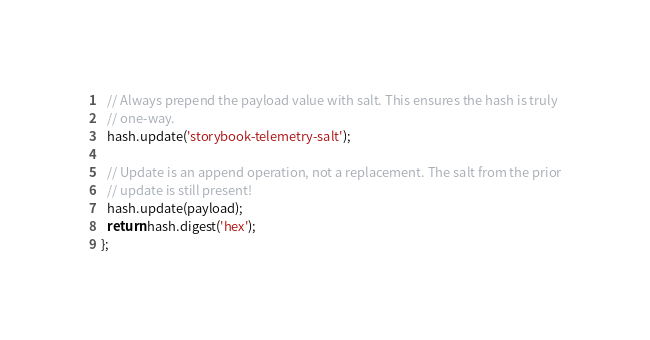Convert code to text. <code><loc_0><loc_0><loc_500><loc_500><_TypeScript_>  // Always prepend the payload value with salt. This ensures the hash is truly
  // one-way.
  hash.update('storybook-telemetry-salt');

  // Update is an append operation, not a replacement. The salt from the prior
  // update is still present!
  hash.update(payload);
  return hash.digest('hex');
};
</code> 